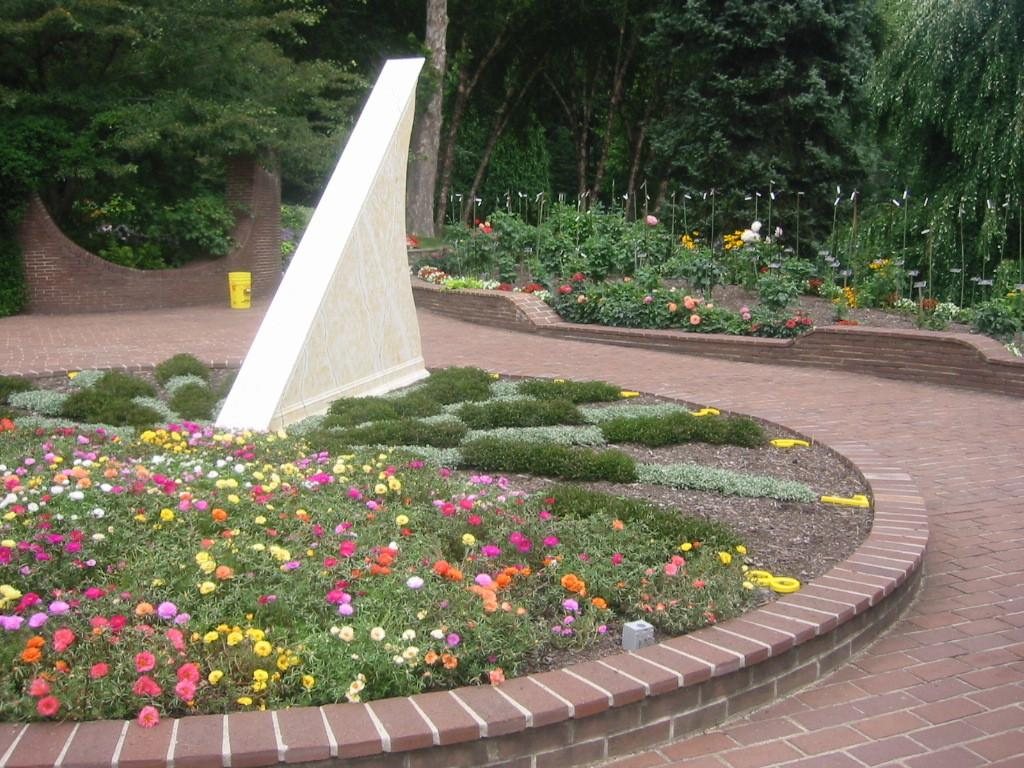What type of plants can be seen in the image? There are plants with flowers in the image. What type of vegetation is present on the ground in the image? There is grass in the image. What is the man-made structure visible in the image? There is a wall in the image. What can be found on the ground in the image? There are objects on the ground in the image. What type of vegetation is visible in the background of the image? There are trees visible in the background of the image. How many lizards are climbing on the wall in the image? There are no lizards present in the image; it only features plants, grass, a wall, objects on the ground, and trees in the background. 